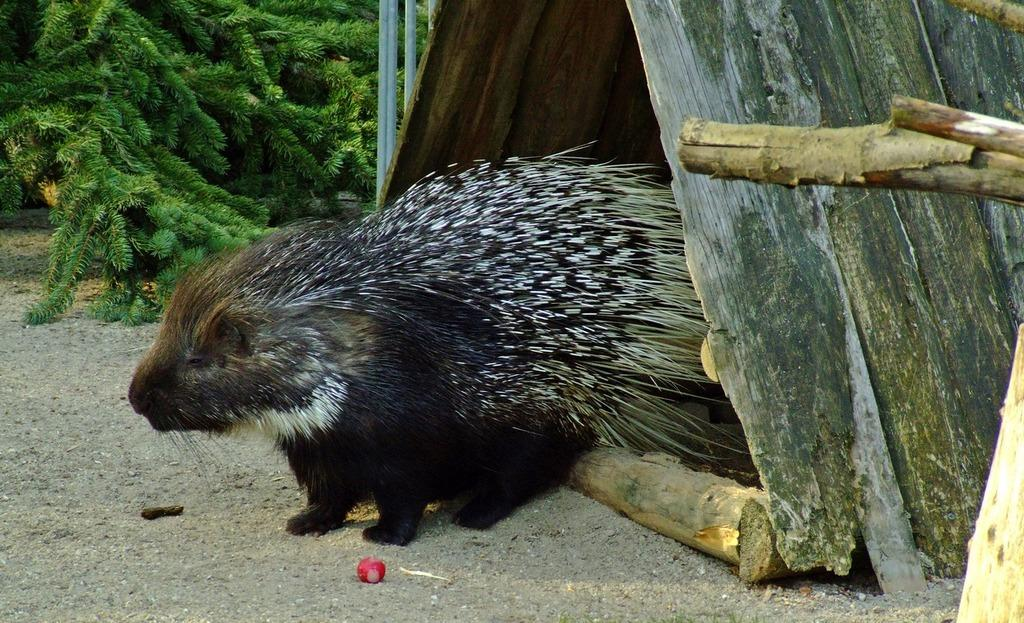What type of living creature is in the image? There is an animal in the image. What structure is present in the image for the animal? There is a pet house in the image. What can be seen beneath the animal and pet house? The ground is visible in the image. What materials are present in the image that might be used for construction or support? There are wooden sticks, rods, and branches in the image. What unidentified object is present in the image? There is an unspecified object in the image. What type of dolls are playing with the bubble in the image? There are no dolls or bubbles present in the image. What can be seen written on the ground using chalk in the image? There is no chalk or writing visible on the ground in the image. 